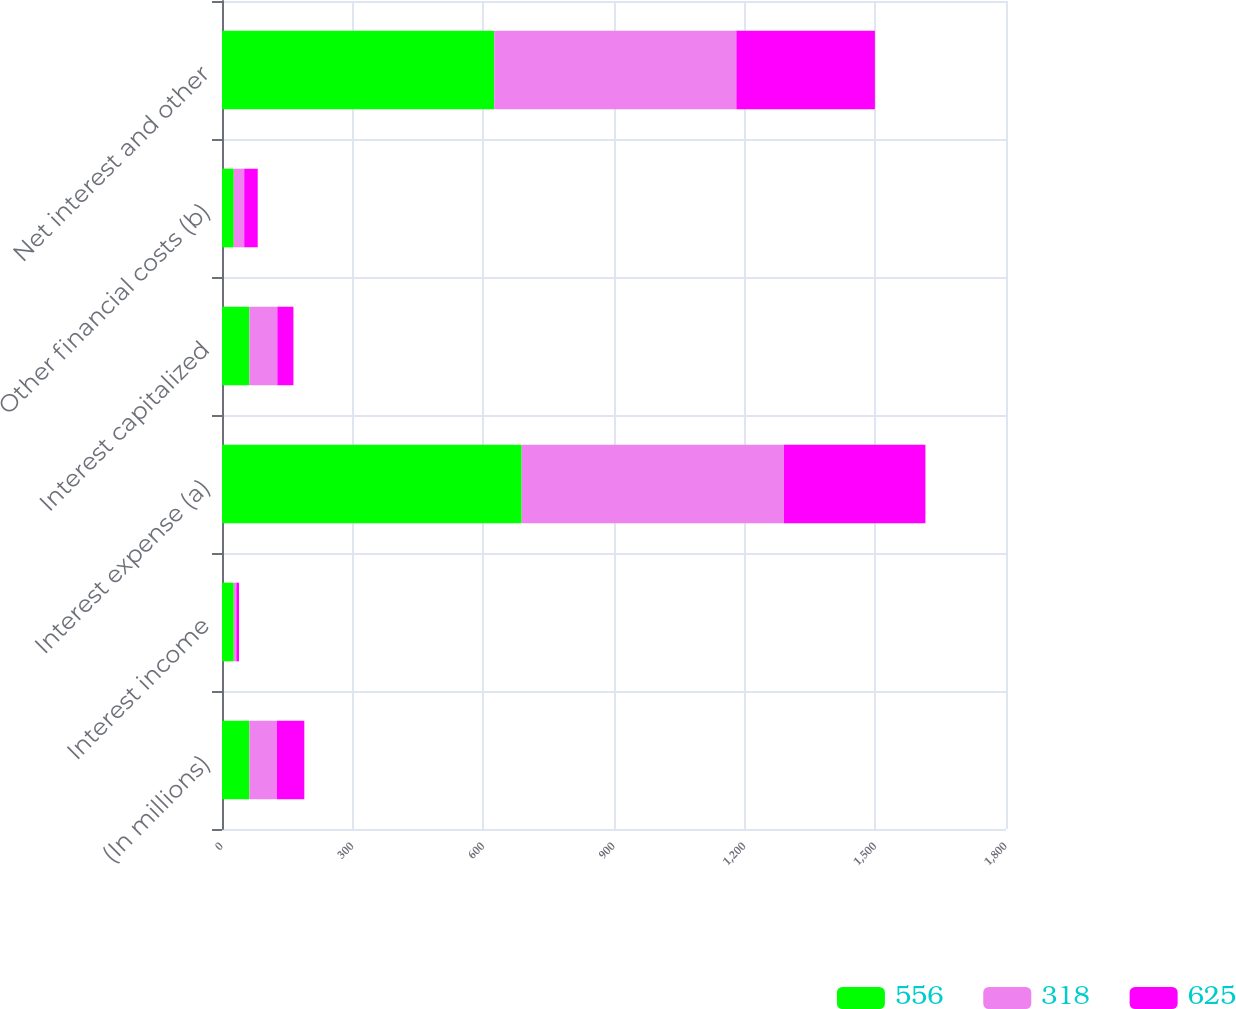Convert chart to OTSL. <chart><loc_0><loc_0><loc_500><loc_500><stacked_bar_chart><ecel><fcel>(In millions)<fcel>Interest income<fcel>Interest expense (a)<fcel>Interest capitalized<fcel>Other financial costs (b)<fcel>Net interest and other<nl><fcel>556<fcel>63<fcel>27<fcel>688<fcel>63<fcel>27<fcel>625<nl><fcel>318<fcel>63<fcel>6<fcel>602<fcel>64<fcel>24<fcel>556<nl><fcel>625<fcel>63<fcel>6<fcel>325<fcel>37<fcel>31<fcel>318<nl></chart> 